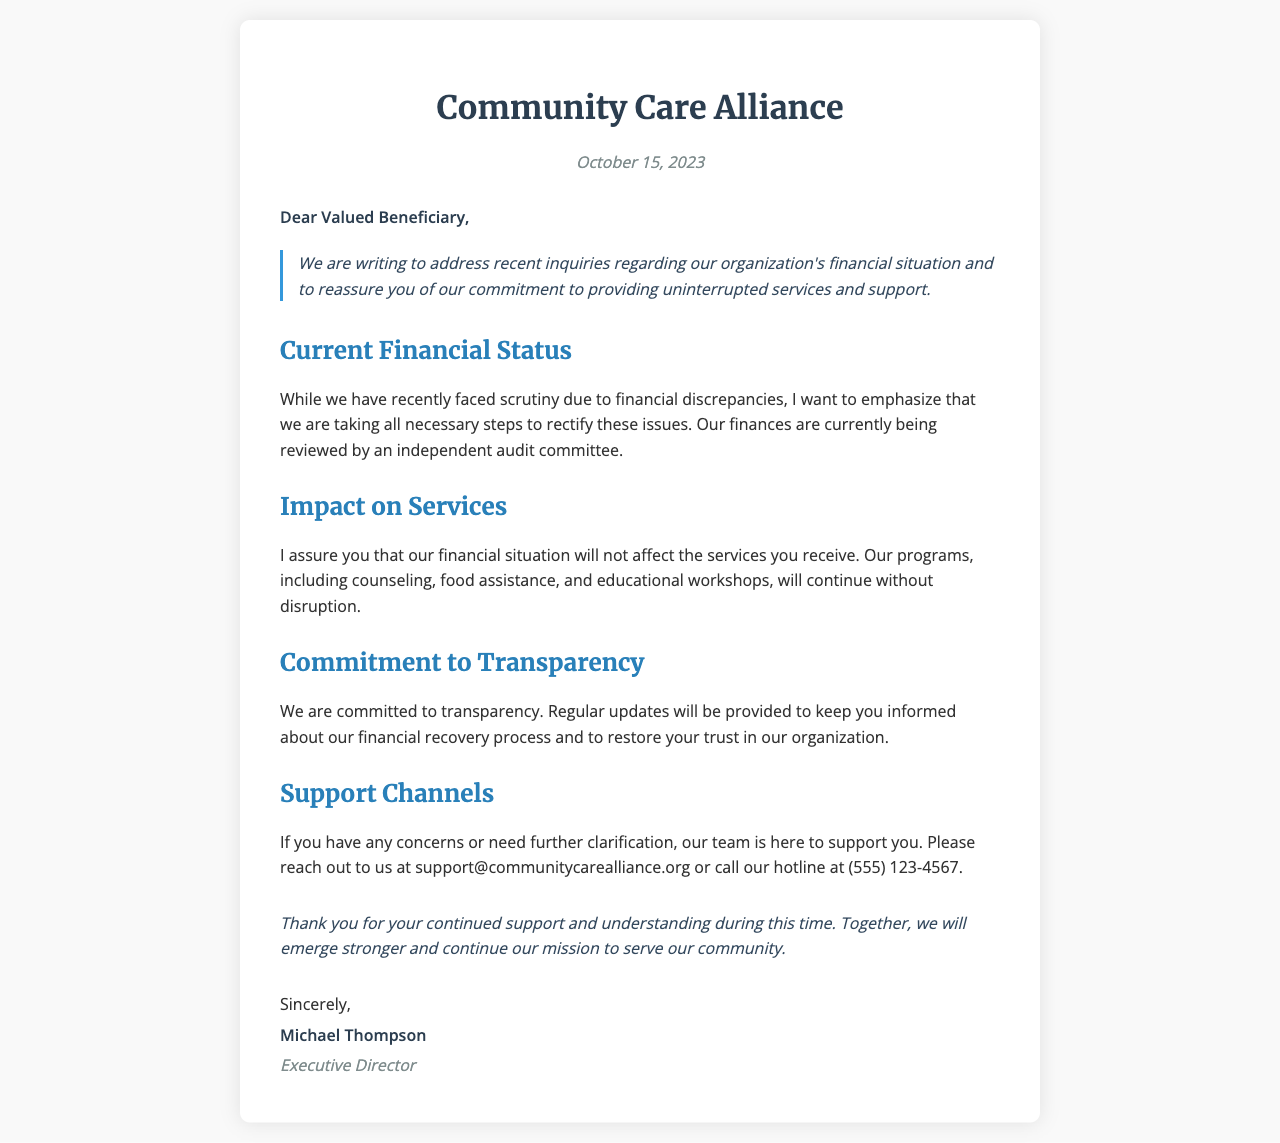What is the name of the organization? The name of the organization mentioned in the letter is Community Care Alliance.
Answer: Community Care Alliance When was this letter written? The date on the letter is mentioned at the top, indicating when it was issued.
Answer: October 15, 2023 Who is the author of the letter? The letter includes a signature section where the author's name is specified.
Answer: Michael Thompson What assurance is given regarding services? The letter explicitly states the organization's commitment to the continuity of services amid financial issues.
Answer: Will continue without disruption What is mentioned as being reviewed by an independent committee? The letter discusses a specific financial review process, indicating transparency and accountability.
Answer: Finances Which types of support programs are mentioned in the letter? The letter lists specific support programs that will continue unaffected by financial scrutiny.
Answer: Counseling, food assistance, educational workshops What is emphasized regarding communication with beneficiaries? The letter encourages beneficiaries to reach out with concerns and specifies the available channels for support.
Answer: Support channels What does the organization commit to providing regularly? The letter indicates a proactive approach to keep beneficiaries informed about financial recovery.
Answer: Regular updates 